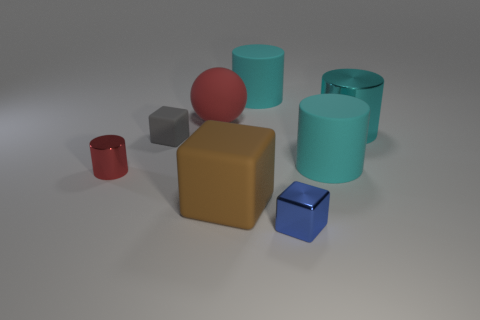How many other things are there of the same shape as the small blue thing?
Your response must be concise. 2. There is a rubber ball; is it the same color as the small block on the left side of the small metallic cube?
Provide a short and direct response. No. Is there anything else that has the same material as the small gray object?
Provide a short and direct response. Yes. There is a large cyan matte object that is in front of the metal cylinder right of the red shiny object; what shape is it?
Provide a short and direct response. Cylinder. The thing that is the same color as the rubber ball is what size?
Your answer should be very brief. Small. There is a red thing that is to the right of the tiny rubber block; is it the same shape as the large cyan metal object?
Ensure brevity in your answer.  No. Is the number of small things that are right of the tiny red shiny object greater than the number of large cubes that are behind the gray block?
Make the answer very short. Yes. There is a matte cube behind the big block; how many small things are left of it?
Your response must be concise. 1. There is a object that is the same color as the large ball; what is it made of?
Offer a terse response. Metal. How many other objects are there of the same color as the big rubber sphere?
Give a very brief answer. 1. 